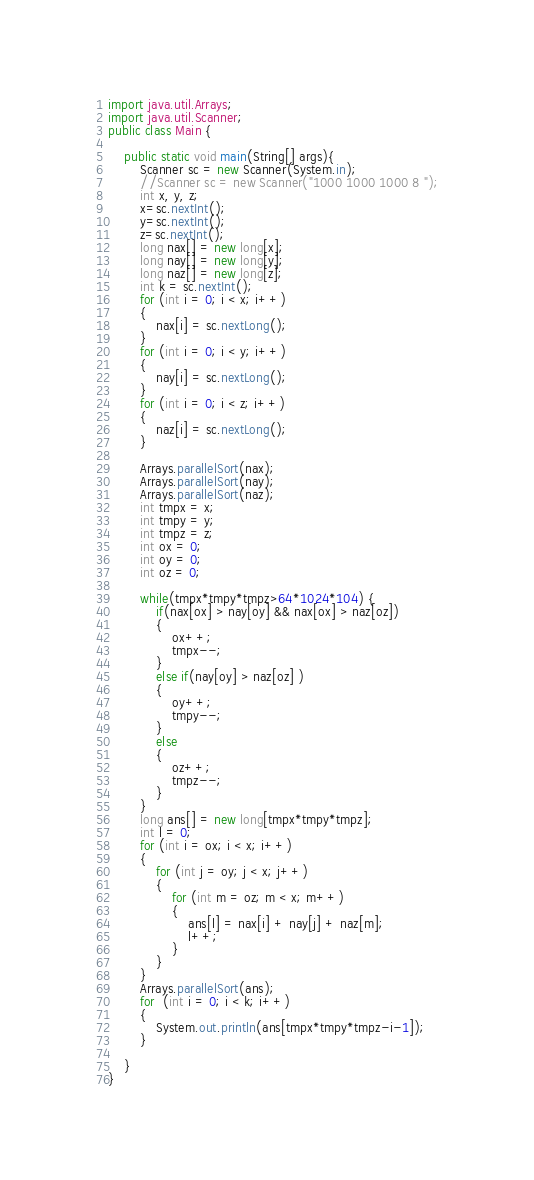Convert code to text. <code><loc_0><loc_0><loc_500><loc_500><_Java_>import java.util.Arrays;
import java.util.Scanner;
public class Main {
	
	public static void main(String[] args){
		Scanner sc = new Scanner(System.in);
		//Scanner sc = new Scanner("1000 1000 1000 8 ");
		int x, y, z;
		x=sc.nextInt();
		y=sc.nextInt();
		z=sc.nextInt();
		long nax[] = new long[x];
		long nay[] = new long[y];
		long naz[] = new long[z];
		int k = sc.nextInt();
		for (int i = 0; i < x; i++)
		{
			nax[i] = sc.nextLong();
		}
		for (int i = 0; i < y; i++)
		{
			nay[i] = sc.nextLong();
		}
		for (int i = 0; i < z; i++)
		{
			naz[i] = sc.nextLong();
		}

		Arrays.parallelSort(nax);
		Arrays.parallelSort(nay);
		Arrays.parallelSort(naz);
		int tmpx = x;
		int tmpy = y;
		int tmpz = z;
		int ox = 0;
		int oy = 0;
		int oz = 0;

		while(tmpx*tmpy*tmpz>64*1024*104) {
			if(nax[ox] > nay[oy] && nax[ox] > naz[oz])
			{
				ox++;
				tmpx--;
			}
			else if(nay[oy] > naz[oz] )
			{
				oy++;
				tmpy--;
			}
			else
			{
				oz++;
				tmpz--;
			}
		}
		long ans[] = new long[tmpx*tmpy*tmpz];
		int l = 0;
		for (int i = ox; i < x; i++)
		{
			for (int j = oy; j < x; j++)
			{
				for (int m = oz; m < x; m++)
				{
					ans[l] = nax[i] + nay[j] + naz[m];
					l++;
				}
			}
		}
		Arrays.parallelSort(ans);
		for  (int i = 0; i < k; i++)
		{
			System.out.println(ans[tmpx*tmpy*tmpz-i-1]);
		}

	}
}</code> 